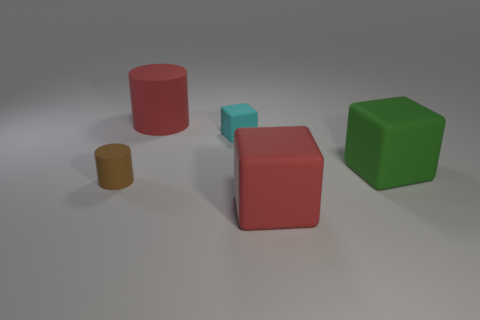Add 3 cylinders. How many objects exist? 8 Subtract all cubes. How many objects are left? 2 Subtract all gray spheres. Subtract all large green rubber blocks. How many objects are left? 4 Add 3 small brown cylinders. How many small brown cylinders are left? 4 Add 2 large rubber blocks. How many large rubber blocks exist? 4 Subtract 0 yellow blocks. How many objects are left? 5 